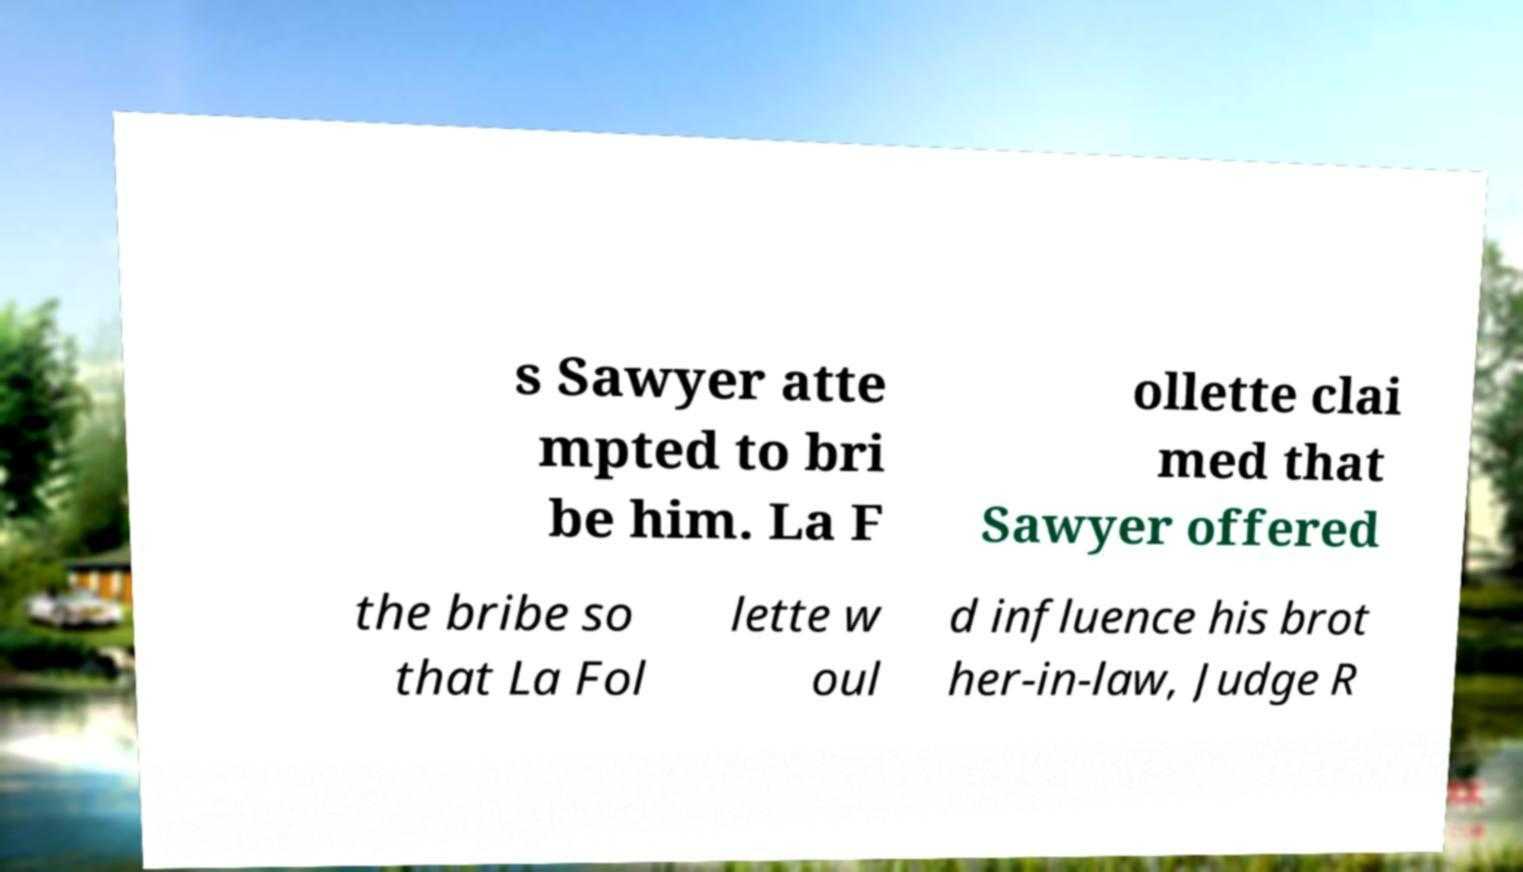Please identify and transcribe the text found in this image. s Sawyer atte mpted to bri be him. La F ollette clai med that Sawyer offered the bribe so that La Fol lette w oul d influence his brot her-in-law, Judge R 